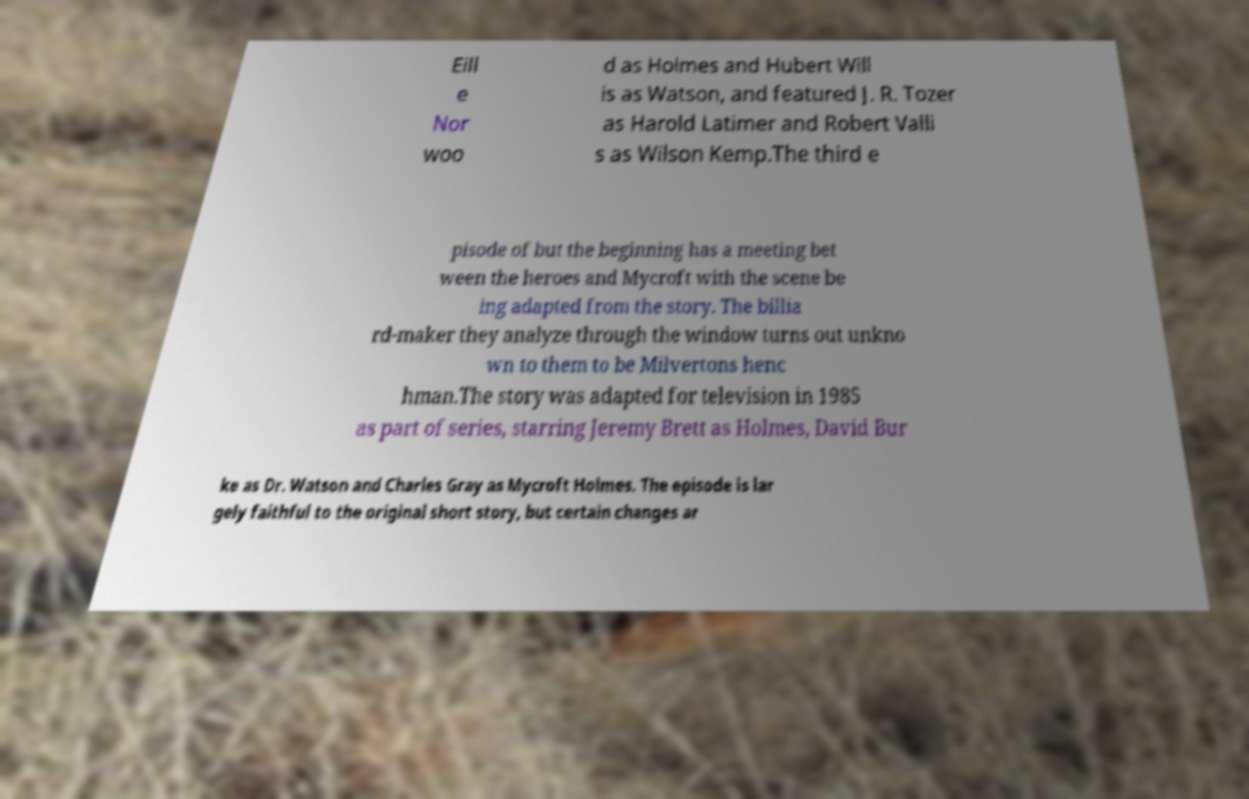There's text embedded in this image that I need extracted. Can you transcribe it verbatim? Eill e Nor woo d as Holmes and Hubert Will is as Watson, and featured J. R. Tozer as Harold Latimer and Robert Valli s as Wilson Kemp.The third e pisode of but the beginning has a meeting bet ween the heroes and Mycroft with the scene be ing adapted from the story. The billia rd-maker they analyze through the window turns out unkno wn to them to be Milvertons henc hman.The story was adapted for television in 1985 as part of series, starring Jeremy Brett as Holmes, David Bur ke as Dr. Watson and Charles Gray as Mycroft Holmes. The episode is lar gely faithful to the original short story, but certain changes ar 